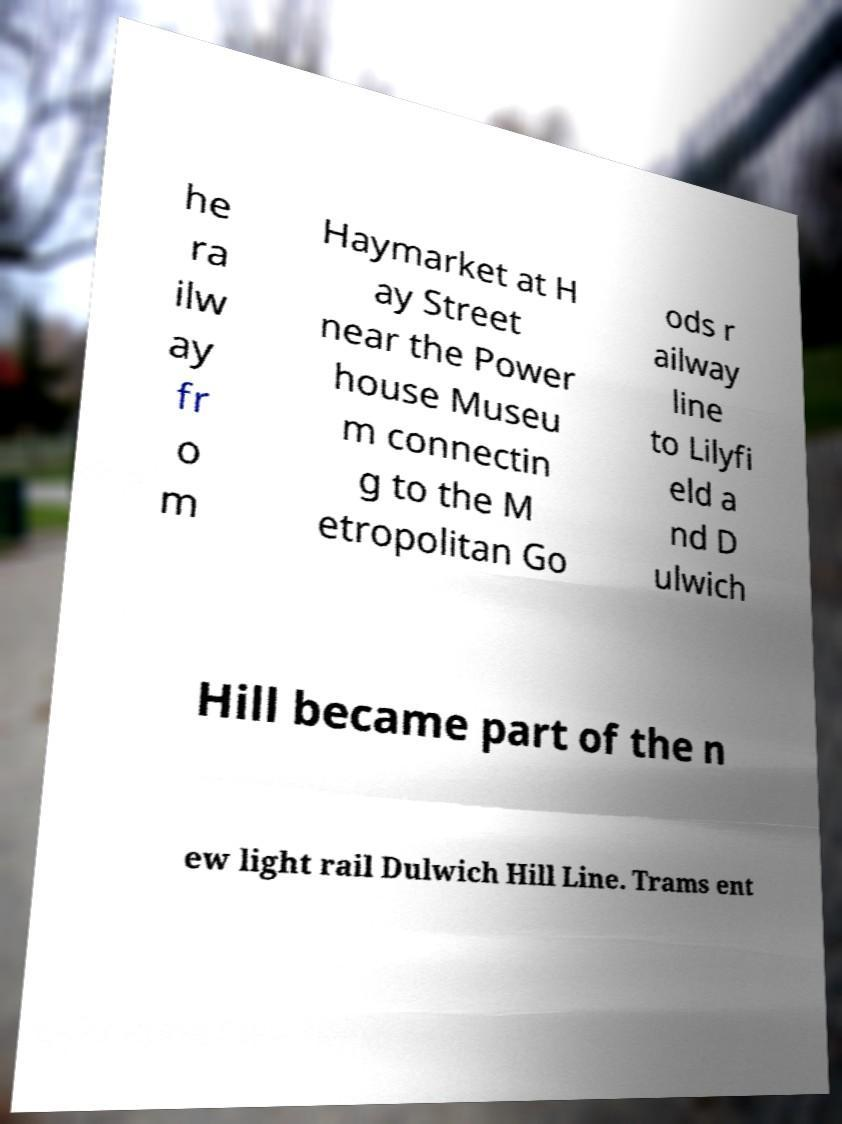Please identify and transcribe the text found in this image. he ra ilw ay fr o m Haymarket at H ay Street near the Power house Museu m connectin g to the M etropolitan Go ods r ailway line to Lilyfi eld a nd D ulwich Hill became part of the n ew light rail Dulwich Hill Line. Trams ent 